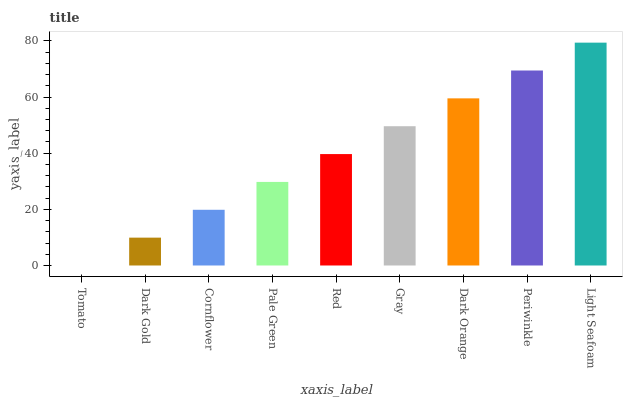Is Tomato the minimum?
Answer yes or no. Yes. Is Light Seafoam the maximum?
Answer yes or no. Yes. Is Dark Gold the minimum?
Answer yes or no. No. Is Dark Gold the maximum?
Answer yes or no. No. Is Dark Gold greater than Tomato?
Answer yes or no. Yes. Is Tomato less than Dark Gold?
Answer yes or no. Yes. Is Tomato greater than Dark Gold?
Answer yes or no. No. Is Dark Gold less than Tomato?
Answer yes or no. No. Is Red the high median?
Answer yes or no. Yes. Is Red the low median?
Answer yes or no. Yes. Is Dark Orange the high median?
Answer yes or no. No. Is Cornflower the low median?
Answer yes or no. No. 